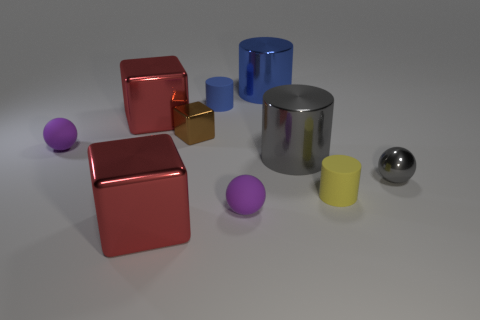Can you describe the lighting of the scene? Where could the light source be coming from? The lighting of the scene is soft and diffuse, casting gentle shadows to the right of the objects, suggesting a light source above and to the left. The lack of harsh shadows or bright highlights indicates that the light source is not extremely close to the objects or exceptionally intense. 